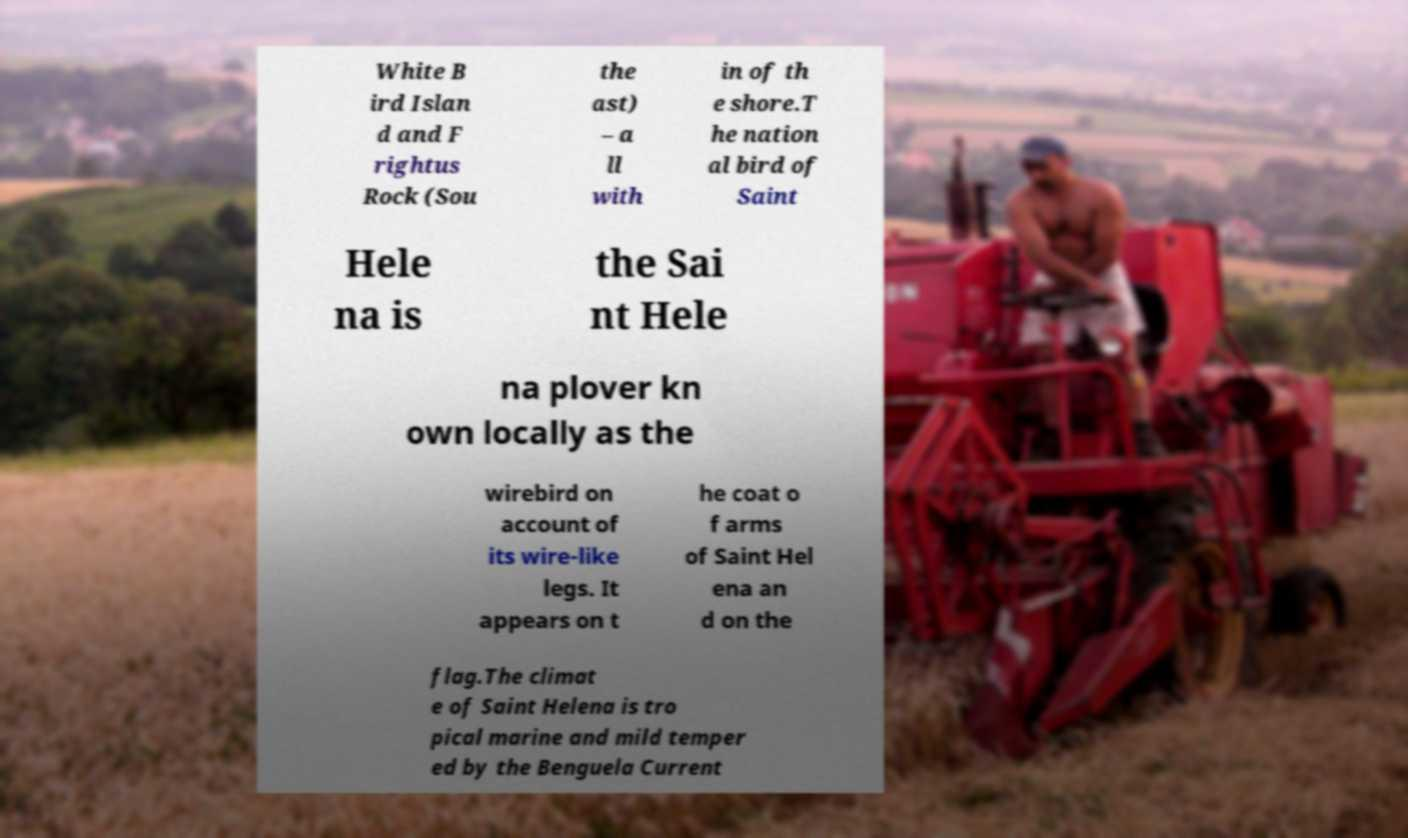Can you read and provide the text displayed in the image?This photo seems to have some interesting text. Can you extract and type it out for me? White B ird Islan d and F rightus Rock (Sou the ast) – a ll with in of th e shore.T he nation al bird of Saint Hele na is the Sai nt Hele na plover kn own locally as the wirebird on account of its wire-like legs. It appears on t he coat o f arms of Saint Hel ena an d on the flag.The climat e of Saint Helena is tro pical marine and mild temper ed by the Benguela Current 